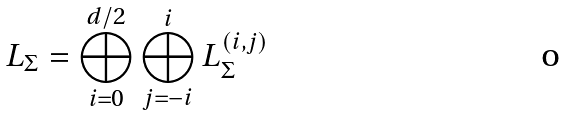Convert formula to latex. <formula><loc_0><loc_0><loc_500><loc_500>L _ { \Sigma } = \bigoplus _ { i = 0 } ^ { d / 2 } \bigoplus _ { j = - i } ^ { i } L ^ { ( i , j ) } _ { \Sigma }</formula> 